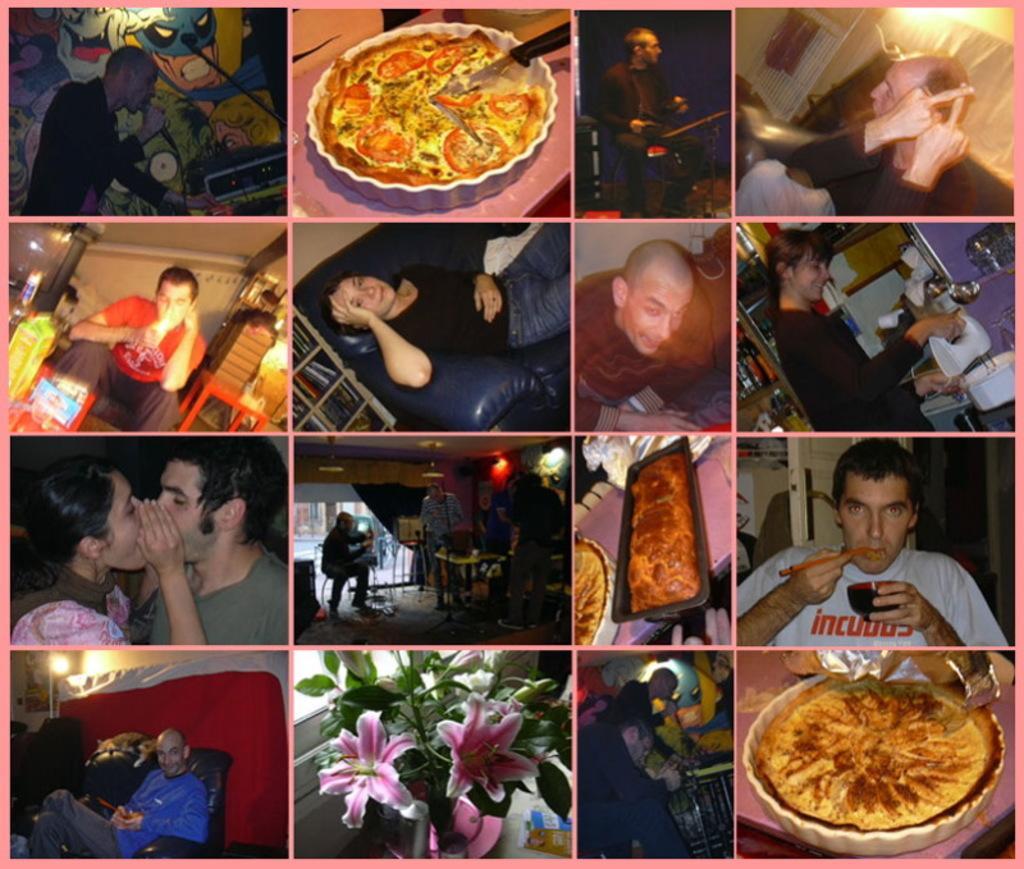How would you summarize this image in a sentence or two? In this image we can see collage images of persons and food. 